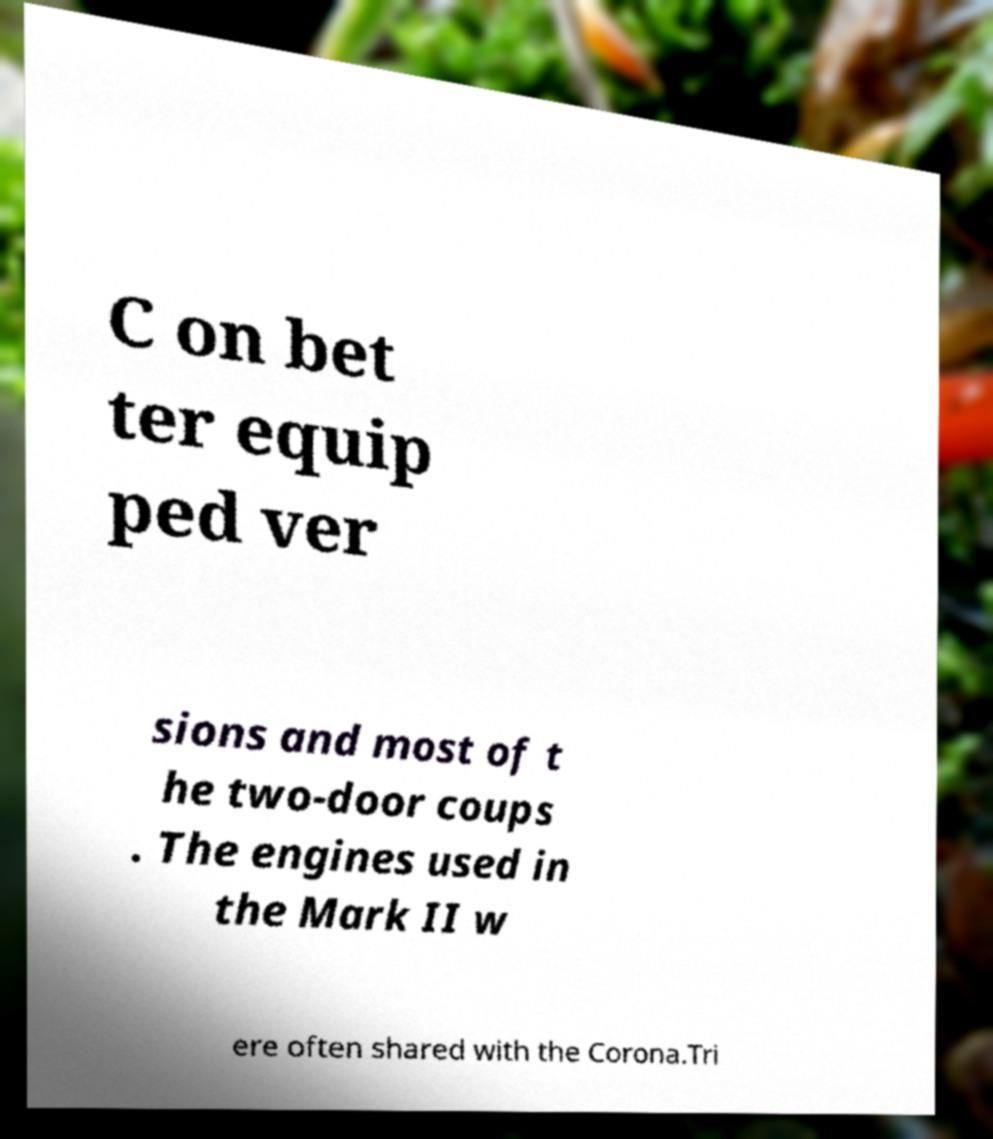I need the written content from this picture converted into text. Can you do that? C on bet ter equip ped ver sions and most of t he two-door coups . The engines used in the Mark II w ere often shared with the Corona.Tri 